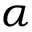Convert formula to latex. <formula><loc_0><loc_0><loc_500><loc_500>\alpha</formula> 